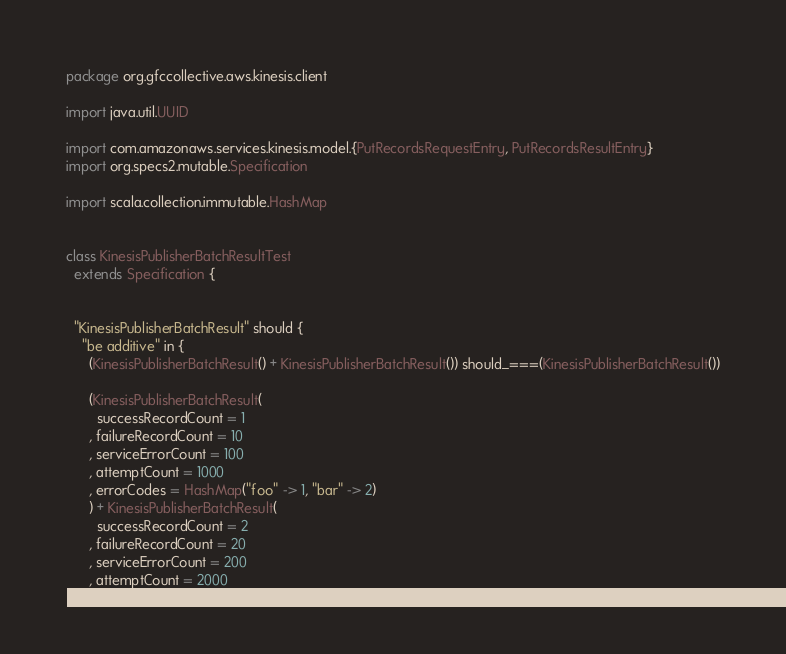Convert code to text. <code><loc_0><loc_0><loc_500><loc_500><_Scala_>package org.gfccollective.aws.kinesis.client

import java.util.UUID

import com.amazonaws.services.kinesis.model.{PutRecordsRequestEntry, PutRecordsResultEntry}
import org.specs2.mutable.Specification

import scala.collection.immutable.HashMap


class KinesisPublisherBatchResultTest
  extends Specification {


  "KinesisPublisherBatchResult" should {
    "be additive" in {
      (KinesisPublisherBatchResult() + KinesisPublisherBatchResult()) should_===(KinesisPublisherBatchResult())

      (KinesisPublisherBatchResult(
        successRecordCount = 1
      , failureRecordCount = 10
      , serviceErrorCount = 100
      , attemptCount = 1000
      , errorCodes = HashMap("foo" -> 1, "bar" -> 2)
      ) + KinesisPublisherBatchResult(
        successRecordCount = 2
      , failureRecordCount = 20
      , serviceErrorCount = 200
      , attemptCount = 2000</code> 